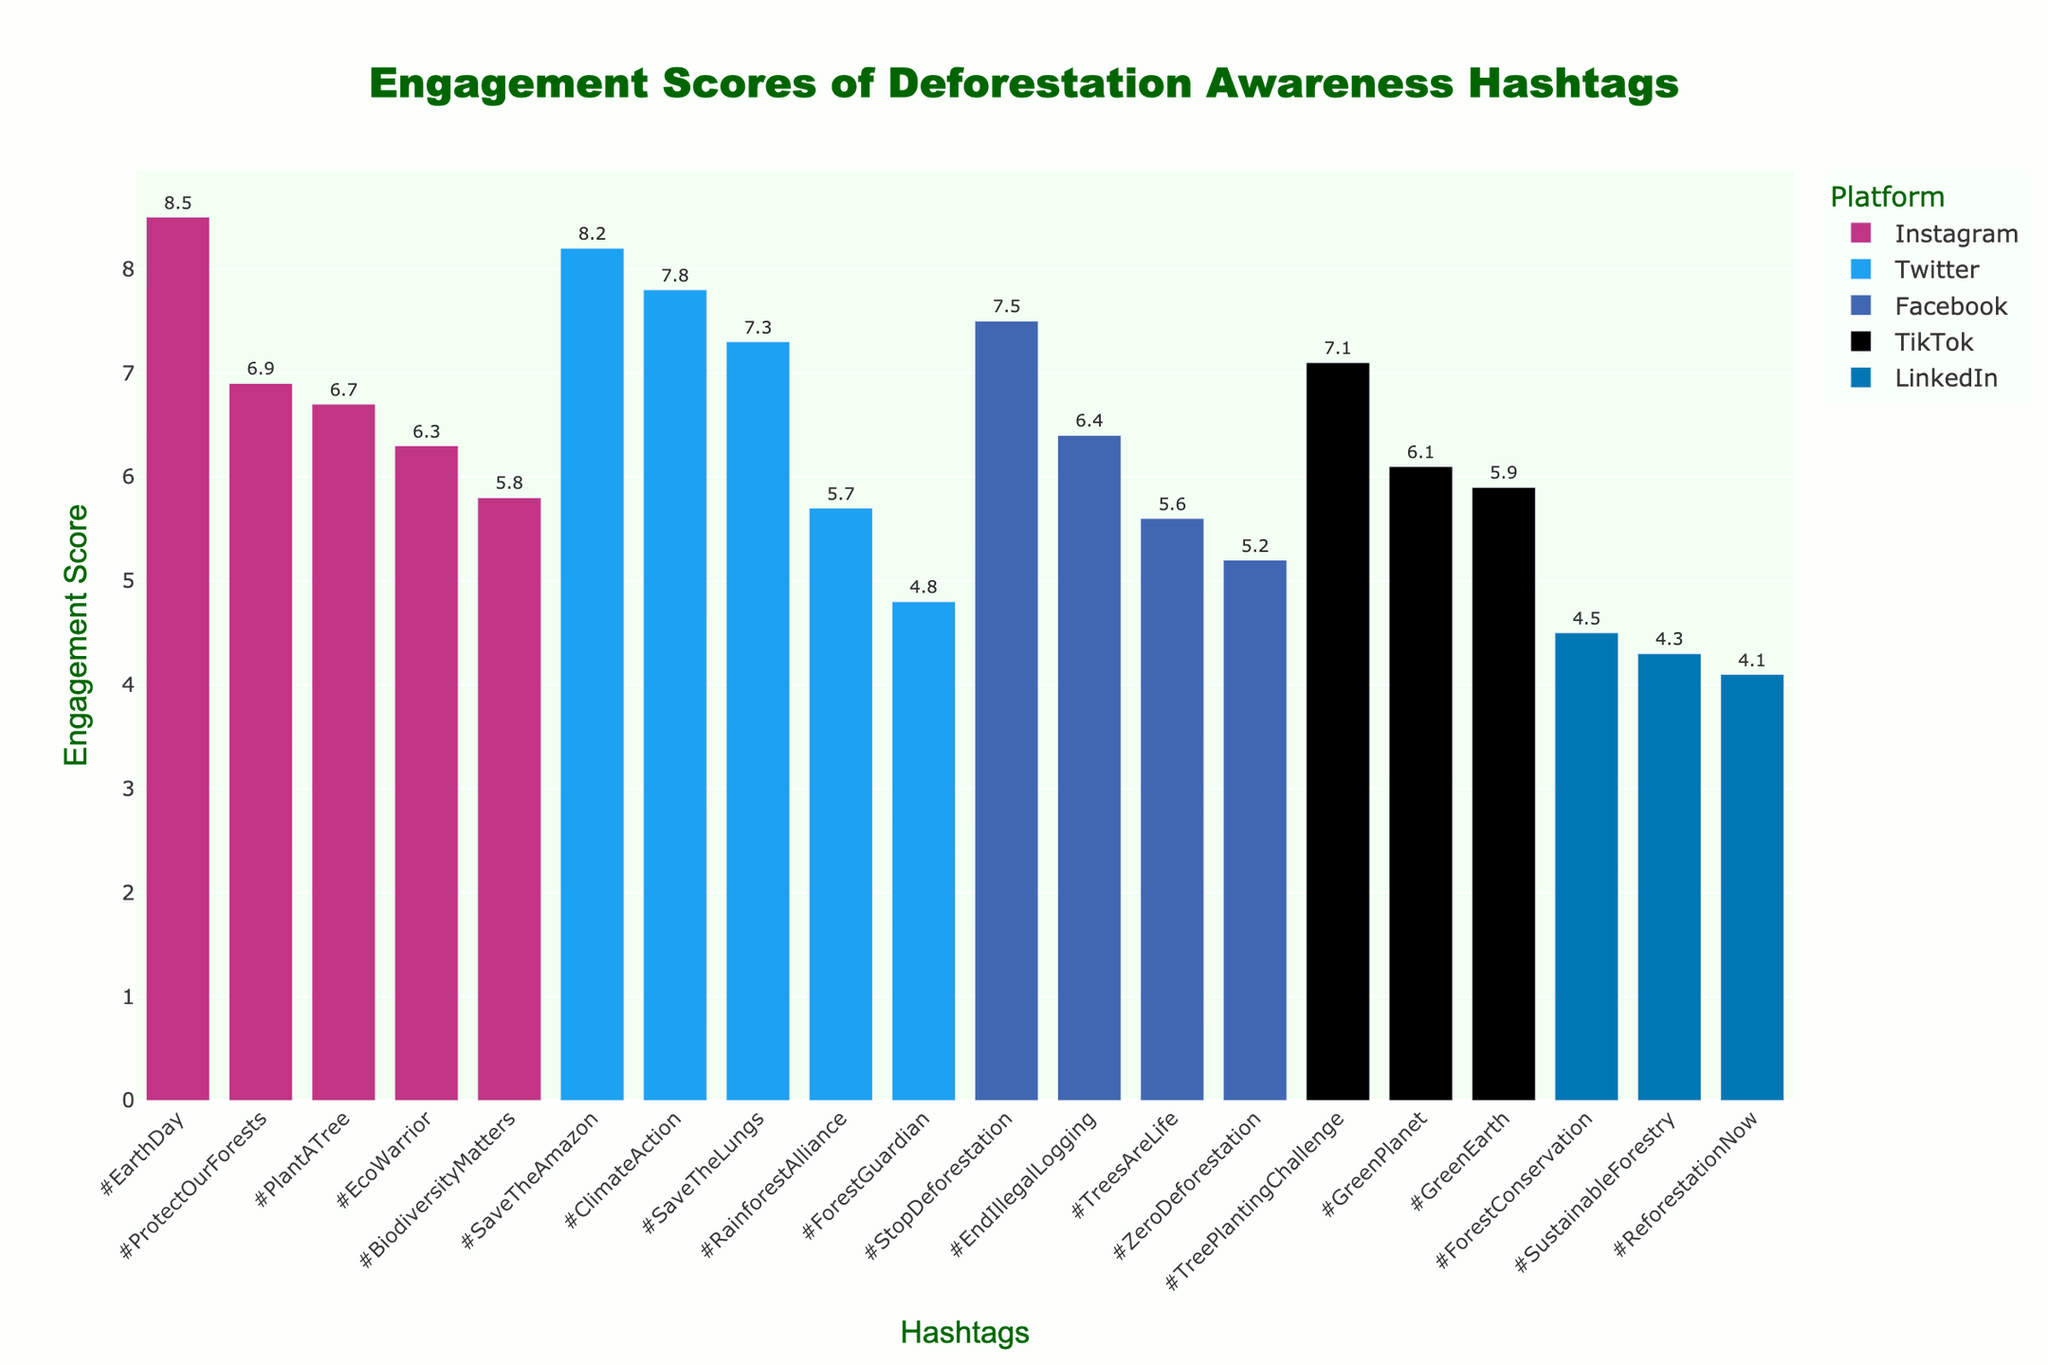Which hashtag has the highest engagement score? By examining the top of the y-axis, we can identify the bar with the greatest height. According to the figure, the highest engagement score belongs to the hashtag '#EarthDay'.
Answer: '#EarthDay' Which platform has the most hashtags represented in the figure? By counting the number of bars for each platform, we can determine that Instagram has the most hashtags represented in the figure.
Answer: 'Instagram' What is the engagement score of the hashtag '#SaveTheAmazon'? Look at the height of the bar representing the hashtag '#SaveTheAmazon' on Twitter. The figure shows an engagement score of 8.2.
Answer: 8.2 Which hashtag on TikTok has the highest engagement score? Among the TikTok bars, the tallest one corresponds to the hashtag '#TreePlantingChallenge', with an engagement score of 7.1.
Answer: '#TreePlantingChallenge' How does the engagement score of '#ClimateAction' on Twitter compare to '#EarthDay' on Instagram? Compare the heights of the respective bars. '#ClimateAction' has an engagement score of 7.8 on Twitter, while '#EarthDay' has an engagement score of 8.5 on Instagram. '#EarthDay' has a higher engagement score.
Answer: '#EarthDay' has a higher engagement score What is the average engagement score of hashtags on LinkedIn? To find the average, add the engagement scores of all LinkedIn hashtags and divide by the number of hashtags: (4.1 + 4.5 + 4.3) / 3 = 4.3.
Answer: 4.3 How many hashtags have engagement scores higher than 7.0? Count the bars that reach above the 7.0 mark. These include '#SaveTheAmazon', '#StopDeforestation', '#ClimateAction', '#SaveTheLungs', '#TreePlantingChallenge', and '#EarthDay', totaling 6 hashtags.
Answer: 6 Which platform has the highest overall engagement score sum for its hashtags? Calculate the sum of engagement scores for each platform and compare: 
Twitter: 8.2 + 4.8 + 7.8 + 7.3 + 5.7 = 33.8 
Instagram: 6.7 + 6.3 + 6.9 + 5.8 + 8.5 = 34.2 
Facebook: 7.5 + 5.6 + 5.2 + 6.4 = 24.7 
TikTok: 5.9 + 6.1 + 7.1 = 19.1 
LinkedIn: 4.1 + 4.5 + 4.3 = 12.9 
Instagram has the highest sum of engagement scores.
Answer: Instagram Compare the engagement scores of the hashtags '#PlantATree' on Instagram and '#ReforestationNow' on LinkedIn. '#PlantATree' on Instagram has an engagement score of 6.7, whereas '#ReforestationNow' on LinkedIn has an engagement score of 4.1. '#PlantATree' has a higher engagement score.
Answer: '#PlantATree' has a higher engagement score What is the difference in engagement scores between the highest and lowest scoring hashtags? The highest engagement score is 8.5 (for '#EarthDay'), and the lowest is 4.1 (for '#ReforestationNow'). The difference is 8.5 - 4.1 = 4.4.
Answer: 4.4 